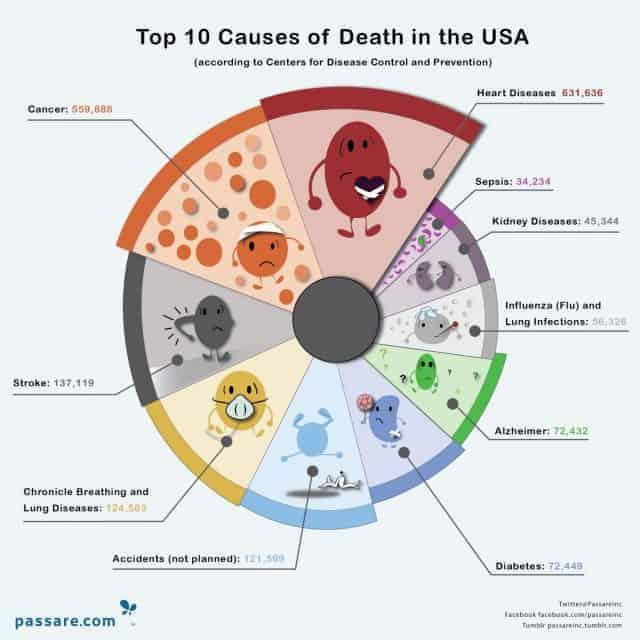what disease is shown in green
Answer the question with a short phrase. alzheimer what is the total death due to sepsis and alzheimer 106,666 death due to cancer is lower than which other disease heart disease what disease is shown in orange cancer 